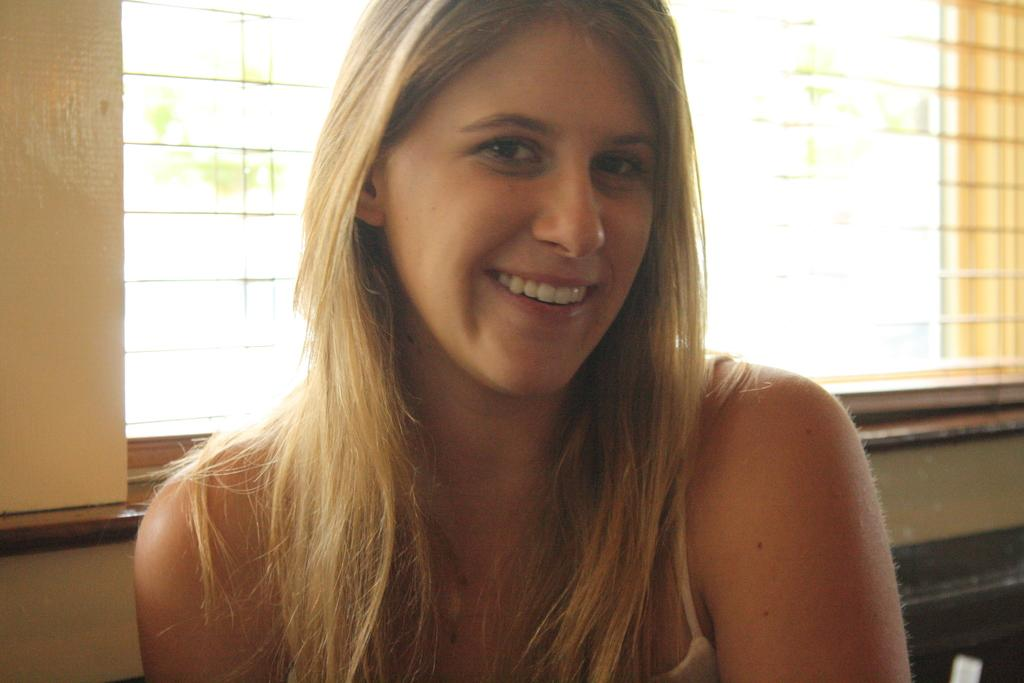Who is the main subject in the image? There is a woman in the image. Where is the woman located in the image? The woman is in the middle of the image. What expression does the woman have? The woman is smiling. What can be seen in the background of the image? There is a window visible in the background of the image. What type of rod is being used to cultivate the field in the image? There is no rod or field present in the image; it features a woman in the middle of the image. 